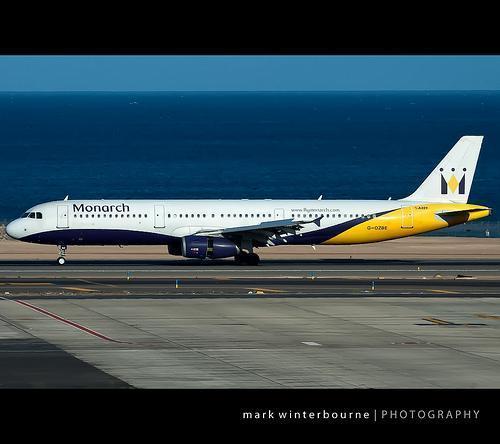How many planes are shown?
Give a very brief answer. 1. 